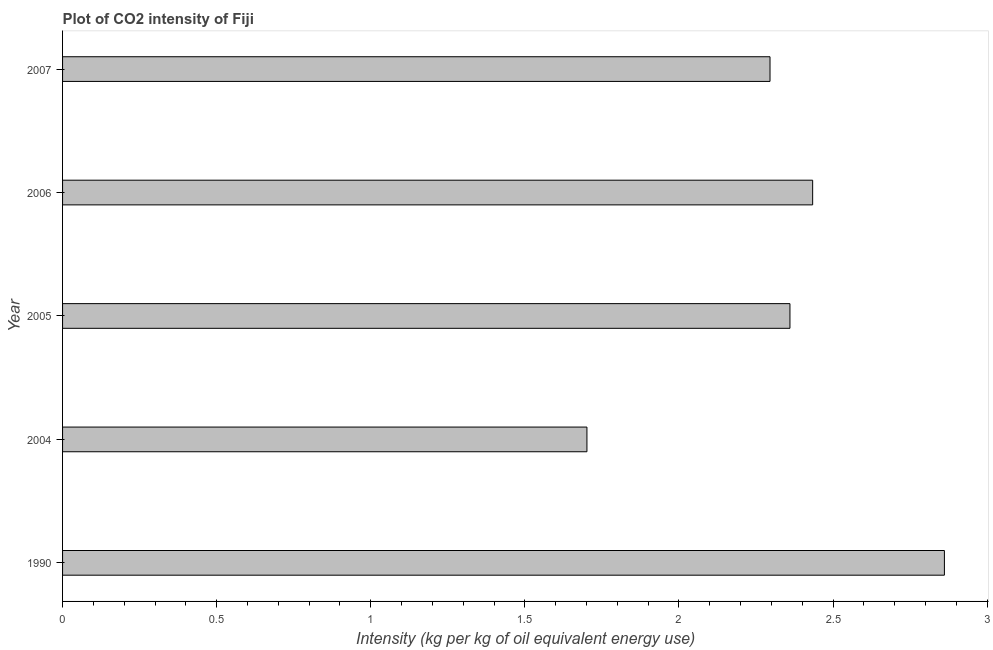Does the graph contain grids?
Offer a very short reply. No. What is the title of the graph?
Make the answer very short. Plot of CO2 intensity of Fiji. What is the label or title of the X-axis?
Provide a succinct answer. Intensity (kg per kg of oil equivalent energy use). What is the label or title of the Y-axis?
Provide a short and direct response. Year. What is the co2 intensity in 2004?
Offer a very short reply. 1.7. Across all years, what is the maximum co2 intensity?
Provide a succinct answer. 2.86. Across all years, what is the minimum co2 intensity?
Your answer should be very brief. 1.7. In which year was the co2 intensity minimum?
Offer a terse response. 2004. What is the sum of the co2 intensity?
Offer a very short reply. 11.65. What is the difference between the co2 intensity in 1990 and 2005?
Keep it short and to the point. 0.5. What is the average co2 intensity per year?
Your answer should be very brief. 2.33. What is the median co2 intensity?
Your answer should be compact. 2.36. In how many years, is the co2 intensity greater than 2.6 kg?
Provide a succinct answer. 1. Do a majority of the years between 2006 and 2007 (inclusive) have co2 intensity greater than 2.2 kg?
Ensure brevity in your answer.  Yes. What is the ratio of the co2 intensity in 1990 to that in 2007?
Provide a succinct answer. 1.25. Is the difference between the co2 intensity in 2005 and 2006 greater than the difference between any two years?
Keep it short and to the point. No. What is the difference between the highest and the second highest co2 intensity?
Your response must be concise. 0.43. Is the sum of the co2 intensity in 2004 and 2007 greater than the maximum co2 intensity across all years?
Make the answer very short. Yes. What is the difference between the highest and the lowest co2 intensity?
Give a very brief answer. 1.16. In how many years, is the co2 intensity greater than the average co2 intensity taken over all years?
Provide a short and direct response. 3. How many bars are there?
Give a very brief answer. 5. Are all the bars in the graph horizontal?
Keep it short and to the point. Yes. How many years are there in the graph?
Offer a terse response. 5. What is the Intensity (kg per kg of oil equivalent energy use) of 1990?
Offer a very short reply. 2.86. What is the Intensity (kg per kg of oil equivalent energy use) of 2004?
Make the answer very short. 1.7. What is the Intensity (kg per kg of oil equivalent energy use) in 2005?
Make the answer very short. 2.36. What is the Intensity (kg per kg of oil equivalent energy use) of 2006?
Your answer should be compact. 2.43. What is the Intensity (kg per kg of oil equivalent energy use) in 2007?
Your answer should be compact. 2.3. What is the difference between the Intensity (kg per kg of oil equivalent energy use) in 1990 and 2004?
Give a very brief answer. 1.16. What is the difference between the Intensity (kg per kg of oil equivalent energy use) in 1990 and 2005?
Your answer should be very brief. 0.5. What is the difference between the Intensity (kg per kg of oil equivalent energy use) in 1990 and 2006?
Provide a short and direct response. 0.43. What is the difference between the Intensity (kg per kg of oil equivalent energy use) in 1990 and 2007?
Offer a terse response. 0.57. What is the difference between the Intensity (kg per kg of oil equivalent energy use) in 2004 and 2005?
Offer a terse response. -0.66. What is the difference between the Intensity (kg per kg of oil equivalent energy use) in 2004 and 2006?
Provide a short and direct response. -0.73. What is the difference between the Intensity (kg per kg of oil equivalent energy use) in 2004 and 2007?
Your answer should be very brief. -0.59. What is the difference between the Intensity (kg per kg of oil equivalent energy use) in 2005 and 2006?
Offer a terse response. -0.07. What is the difference between the Intensity (kg per kg of oil equivalent energy use) in 2005 and 2007?
Keep it short and to the point. 0.06. What is the difference between the Intensity (kg per kg of oil equivalent energy use) in 2006 and 2007?
Provide a short and direct response. 0.14. What is the ratio of the Intensity (kg per kg of oil equivalent energy use) in 1990 to that in 2004?
Provide a short and direct response. 1.68. What is the ratio of the Intensity (kg per kg of oil equivalent energy use) in 1990 to that in 2005?
Your answer should be compact. 1.21. What is the ratio of the Intensity (kg per kg of oil equivalent energy use) in 1990 to that in 2006?
Make the answer very short. 1.18. What is the ratio of the Intensity (kg per kg of oil equivalent energy use) in 1990 to that in 2007?
Offer a very short reply. 1.25. What is the ratio of the Intensity (kg per kg of oil equivalent energy use) in 2004 to that in 2005?
Make the answer very short. 0.72. What is the ratio of the Intensity (kg per kg of oil equivalent energy use) in 2004 to that in 2006?
Offer a terse response. 0.7. What is the ratio of the Intensity (kg per kg of oil equivalent energy use) in 2004 to that in 2007?
Provide a succinct answer. 0.74. What is the ratio of the Intensity (kg per kg of oil equivalent energy use) in 2005 to that in 2006?
Give a very brief answer. 0.97. What is the ratio of the Intensity (kg per kg of oil equivalent energy use) in 2005 to that in 2007?
Offer a terse response. 1.03. What is the ratio of the Intensity (kg per kg of oil equivalent energy use) in 2006 to that in 2007?
Your answer should be compact. 1.06. 